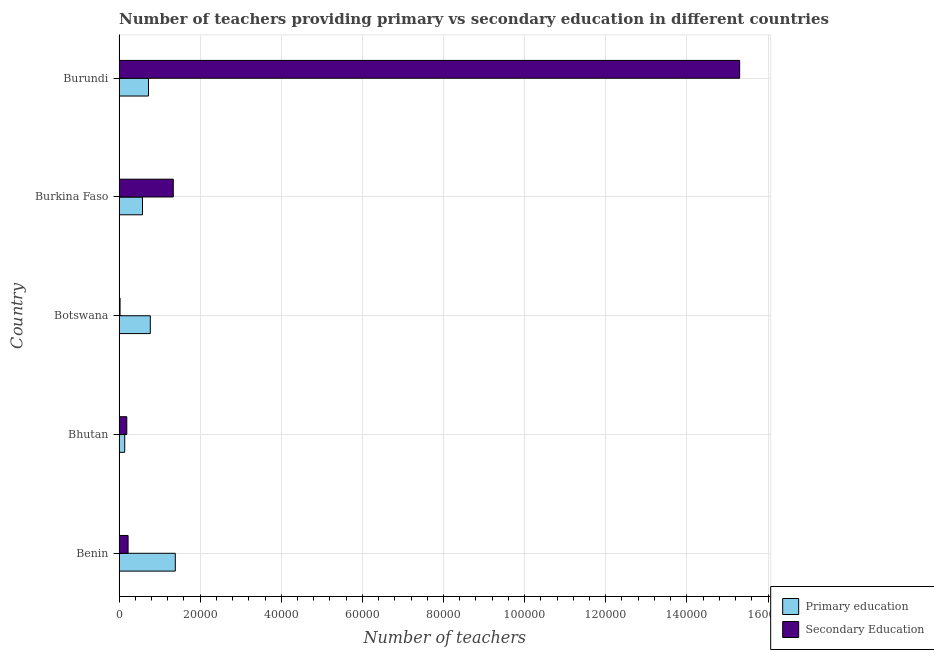How many different coloured bars are there?
Make the answer very short. 2. Are the number of bars on each tick of the Y-axis equal?
Your response must be concise. Yes. How many bars are there on the 3rd tick from the top?
Keep it short and to the point. 2. What is the label of the 4th group of bars from the top?
Offer a very short reply. Bhutan. In how many cases, is the number of bars for a given country not equal to the number of legend labels?
Keep it short and to the point. 0. What is the number of primary teachers in Burundi?
Keep it short and to the point. 7256. Across all countries, what is the maximum number of secondary teachers?
Your answer should be compact. 1.53e+05. Across all countries, what is the minimum number of primary teachers?
Offer a very short reply. 1398. In which country was the number of primary teachers maximum?
Make the answer very short. Benin. In which country was the number of secondary teachers minimum?
Make the answer very short. Botswana. What is the total number of secondary teachers in the graph?
Provide a short and direct response. 1.71e+05. What is the difference between the number of secondary teachers in Burkina Faso and that in Burundi?
Make the answer very short. -1.40e+05. What is the difference between the number of primary teachers in Burundi and the number of secondary teachers in Benin?
Keep it short and to the point. 5030. What is the average number of secondary teachers per country?
Offer a very short reply. 3.42e+04. What is the difference between the number of primary teachers and number of secondary teachers in Burundi?
Ensure brevity in your answer.  -1.46e+05. In how many countries, is the number of primary teachers greater than 48000 ?
Make the answer very short. 0. What is the ratio of the number of primary teachers in Benin to that in Bhutan?
Keep it short and to the point. 9.92. Is the difference between the number of primary teachers in Benin and Burundi greater than the difference between the number of secondary teachers in Benin and Burundi?
Offer a very short reply. Yes. What is the difference between the highest and the second highest number of primary teachers?
Your response must be concise. 6163. What is the difference between the highest and the lowest number of secondary teachers?
Keep it short and to the point. 1.53e+05. What does the 1st bar from the top in Bhutan represents?
Your answer should be compact. Secondary Education. What does the 1st bar from the bottom in Botswana represents?
Provide a short and direct response. Primary education. Are all the bars in the graph horizontal?
Provide a short and direct response. Yes. What is the difference between two consecutive major ticks on the X-axis?
Ensure brevity in your answer.  2.00e+04. Does the graph contain any zero values?
Your answer should be very brief. No. Where does the legend appear in the graph?
Your answer should be compact. Bottom right. How are the legend labels stacked?
Keep it short and to the point. Vertical. What is the title of the graph?
Your response must be concise. Number of teachers providing primary vs secondary education in different countries. Does "Urban" appear as one of the legend labels in the graph?
Provide a succinct answer. No. What is the label or title of the X-axis?
Keep it short and to the point. Number of teachers. What is the label or title of the Y-axis?
Make the answer very short. Country. What is the Number of teachers in Primary education in Benin?
Keep it short and to the point. 1.39e+04. What is the Number of teachers in Secondary Education in Benin?
Offer a very short reply. 2226. What is the Number of teachers of Primary education in Bhutan?
Your answer should be compact. 1398. What is the Number of teachers of Secondary Education in Bhutan?
Your answer should be very brief. 1908. What is the Number of teachers in Primary education in Botswana?
Your response must be concise. 7704. What is the Number of teachers of Secondary Education in Botswana?
Ensure brevity in your answer.  247. What is the Number of teachers of Primary education in Burkina Faso?
Offer a very short reply. 5780. What is the Number of teachers of Secondary Education in Burkina Faso?
Offer a terse response. 1.34e+04. What is the Number of teachers of Primary education in Burundi?
Offer a terse response. 7256. What is the Number of teachers in Secondary Education in Burundi?
Make the answer very short. 1.53e+05. Across all countries, what is the maximum Number of teachers in Primary education?
Make the answer very short. 1.39e+04. Across all countries, what is the maximum Number of teachers in Secondary Education?
Your answer should be compact. 1.53e+05. Across all countries, what is the minimum Number of teachers of Primary education?
Your response must be concise. 1398. Across all countries, what is the minimum Number of teachers of Secondary Education?
Your answer should be very brief. 247. What is the total Number of teachers in Primary education in the graph?
Your answer should be very brief. 3.60e+04. What is the total Number of teachers of Secondary Education in the graph?
Provide a short and direct response. 1.71e+05. What is the difference between the Number of teachers of Primary education in Benin and that in Bhutan?
Make the answer very short. 1.25e+04. What is the difference between the Number of teachers of Secondary Education in Benin and that in Bhutan?
Keep it short and to the point. 318. What is the difference between the Number of teachers of Primary education in Benin and that in Botswana?
Offer a very short reply. 6163. What is the difference between the Number of teachers of Secondary Education in Benin and that in Botswana?
Provide a succinct answer. 1979. What is the difference between the Number of teachers of Primary education in Benin and that in Burkina Faso?
Offer a very short reply. 8087. What is the difference between the Number of teachers in Secondary Education in Benin and that in Burkina Faso?
Provide a succinct answer. -1.11e+04. What is the difference between the Number of teachers of Primary education in Benin and that in Burundi?
Ensure brevity in your answer.  6611. What is the difference between the Number of teachers of Secondary Education in Benin and that in Burundi?
Your answer should be very brief. -1.51e+05. What is the difference between the Number of teachers in Primary education in Bhutan and that in Botswana?
Keep it short and to the point. -6306. What is the difference between the Number of teachers of Secondary Education in Bhutan and that in Botswana?
Your response must be concise. 1661. What is the difference between the Number of teachers in Primary education in Bhutan and that in Burkina Faso?
Your answer should be compact. -4382. What is the difference between the Number of teachers of Secondary Education in Bhutan and that in Burkina Faso?
Offer a very short reply. -1.15e+04. What is the difference between the Number of teachers in Primary education in Bhutan and that in Burundi?
Your answer should be very brief. -5858. What is the difference between the Number of teachers in Secondary Education in Bhutan and that in Burundi?
Provide a succinct answer. -1.51e+05. What is the difference between the Number of teachers in Primary education in Botswana and that in Burkina Faso?
Offer a terse response. 1924. What is the difference between the Number of teachers of Secondary Education in Botswana and that in Burkina Faso?
Ensure brevity in your answer.  -1.31e+04. What is the difference between the Number of teachers of Primary education in Botswana and that in Burundi?
Give a very brief answer. 448. What is the difference between the Number of teachers of Secondary Education in Botswana and that in Burundi?
Your answer should be compact. -1.53e+05. What is the difference between the Number of teachers in Primary education in Burkina Faso and that in Burundi?
Your answer should be very brief. -1476. What is the difference between the Number of teachers of Secondary Education in Burkina Faso and that in Burundi?
Your answer should be very brief. -1.40e+05. What is the difference between the Number of teachers of Primary education in Benin and the Number of teachers of Secondary Education in Bhutan?
Keep it short and to the point. 1.20e+04. What is the difference between the Number of teachers in Primary education in Benin and the Number of teachers in Secondary Education in Botswana?
Offer a very short reply. 1.36e+04. What is the difference between the Number of teachers in Primary education in Benin and the Number of teachers in Secondary Education in Burkina Faso?
Provide a succinct answer. 497. What is the difference between the Number of teachers in Primary education in Benin and the Number of teachers in Secondary Education in Burundi?
Offer a very short reply. -1.39e+05. What is the difference between the Number of teachers in Primary education in Bhutan and the Number of teachers in Secondary Education in Botswana?
Ensure brevity in your answer.  1151. What is the difference between the Number of teachers of Primary education in Bhutan and the Number of teachers of Secondary Education in Burkina Faso?
Provide a short and direct response. -1.20e+04. What is the difference between the Number of teachers in Primary education in Bhutan and the Number of teachers in Secondary Education in Burundi?
Offer a very short reply. -1.52e+05. What is the difference between the Number of teachers in Primary education in Botswana and the Number of teachers in Secondary Education in Burkina Faso?
Provide a short and direct response. -5666. What is the difference between the Number of teachers of Primary education in Botswana and the Number of teachers of Secondary Education in Burundi?
Provide a succinct answer. -1.45e+05. What is the difference between the Number of teachers in Primary education in Burkina Faso and the Number of teachers in Secondary Education in Burundi?
Offer a terse response. -1.47e+05. What is the average Number of teachers in Primary education per country?
Ensure brevity in your answer.  7201. What is the average Number of teachers of Secondary Education per country?
Provide a short and direct response. 3.42e+04. What is the difference between the Number of teachers in Primary education and Number of teachers in Secondary Education in Benin?
Provide a succinct answer. 1.16e+04. What is the difference between the Number of teachers in Primary education and Number of teachers in Secondary Education in Bhutan?
Provide a short and direct response. -510. What is the difference between the Number of teachers in Primary education and Number of teachers in Secondary Education in Botswana?
Your response must be concise. 7457. What is the difference between the Number of teachers in Primary education and Number of teachers in Secondary Education in Burkina Faso?
Provide a short and direct response. -7590. What is the difference between the Number of teachers in Primary education and Number of teachers in Secondary Education in Burundi?
Offer a terse response. -1.46e+05. What is the ratio of the Number of teachers in Primary education in Benin to that in Bhutan?
Offer a very short reply. 9.92. What is the ratio of the Number of teachers of Primary education in Benin to that in Botswana?
Keep it short and to the point. 1.8. What is the ratio of the Number of teachers in Secondary Education in Benin to that in Botswana?
Provide a short and direct response. 9.01. What is the ratio of the Number of teachers in Primary education in Benin to that in Burkina Faso?
Offer a very short reply. 2.4. What is the ratio of the Number of teachers of Secondary Education in Benin to that in Burkina Faso?
Ensure brevity in your answer.  0.17. What is the ratio of the Number of teachers in Primary education in Benin to that in Burundi?
Your answer should be compact. 1.91. What is the ratio of the Number of teachers in Secondary Education in Benin to that in Burundi?
Ensure brevity in your answer.  0.01. What is the ratio of the Number of teachers of Primary education in Bhutan to that in Botswana?
Ensure brevity in your answer.  0.18. What is the ratio of the Number of teachers in Secondary Education in Bhutan to that in Botswana?
Provide a short and direct response. 7.72. What is the ratio of the Number of teachers of Primary education in Bhutan to that in Burkina Faso?
Ensure brevity in your answer.  0.24. What is the ratio of the Number of teachers of Secondary Education in Bhutan to that in Burkina Faso?
Provide a succinct answer. 0.14. What is the ratio of the Number of teachers of Primary education in Bhutan to that in Burundi?
Provide a short and direct response. 0.19. What is the ratio of the Number of teachers in Secondary Education in Bhutan to that in Burundi?
Keep it short and to the point. 0.01. What is the ratio of the Number of teachers in Primary education in Botswana to that in Burkina Faso?
Make the answer very short. 1.33. What is the ratio of the Number of teachers in Secondary Education in Botswana to that in Burkina Faso?
Give a very brief answer. 0.02. What is the ratio of the Number of teachers of Primary education in Botswana to that in Burundi?
Make the answer very short. 1.06. What is the ratio of the Number of teachers in Secondary Education in Botswana to that in Burundi?
Give a very brief answer. 0. What is the ratio of the Number of teachers of Primary education in Burkina Faso to that in Burundi?
Provide a short and direct response. 0.8. What is the ratio of the Number of teachers of Secondary Education in Burkina Faso to that in Burundi?
Ensure brevity in your answer.  0.09. What is the difference between the highest and the second highest Number of teachers in Primary education?
Offer a terse response. 6163. What is the difference between the highest and the second highest Number of teachers in Secondary Education?
Keep it short and to the point. 1.40e+05. What is the difference between the highest and the lowest Number of teachers of Primary education?
Provide a succinct answer. 1.25e+04. What is the difference between the highest and the lowest Number of teachers in Secondary Education?
Make the answer very short. 1.53e+05. 